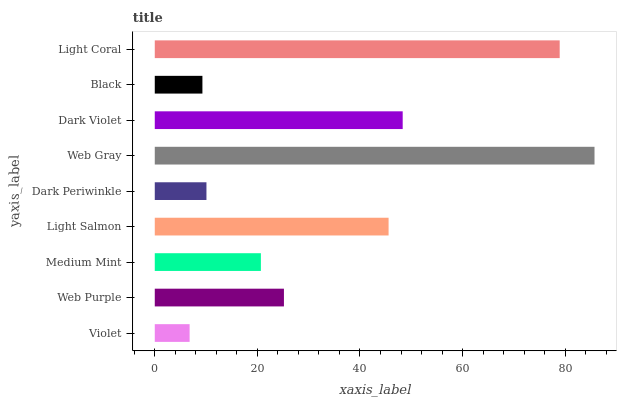Is Violet the minimum?
Answer yes or no. Yes. Is Web Gray the maximum?
Answer yes or no. Yes. Is Web Purple the minimum?
Answer yes or no. No. Is Web Purple the maximum?
Answer yes or no. No. Is Web Purple greater than Violet?
Answer yes or no. Yes. Is Violet less than Web Purple?
Answer yes or no. Yes. Is Violet greater than Web Purple?
Answer yes or no. No. Is Web Purple less than Violet?
Answer yes or no. No. Is Web Purple the high median?
Answer yes or no. Yes. Is Web Purple the low median?
Answer yes or no. Yes. Is Web Gray the high median?
Answer yes or no. No. Is Light Salmon the low median?
Answer yes or no. No. 